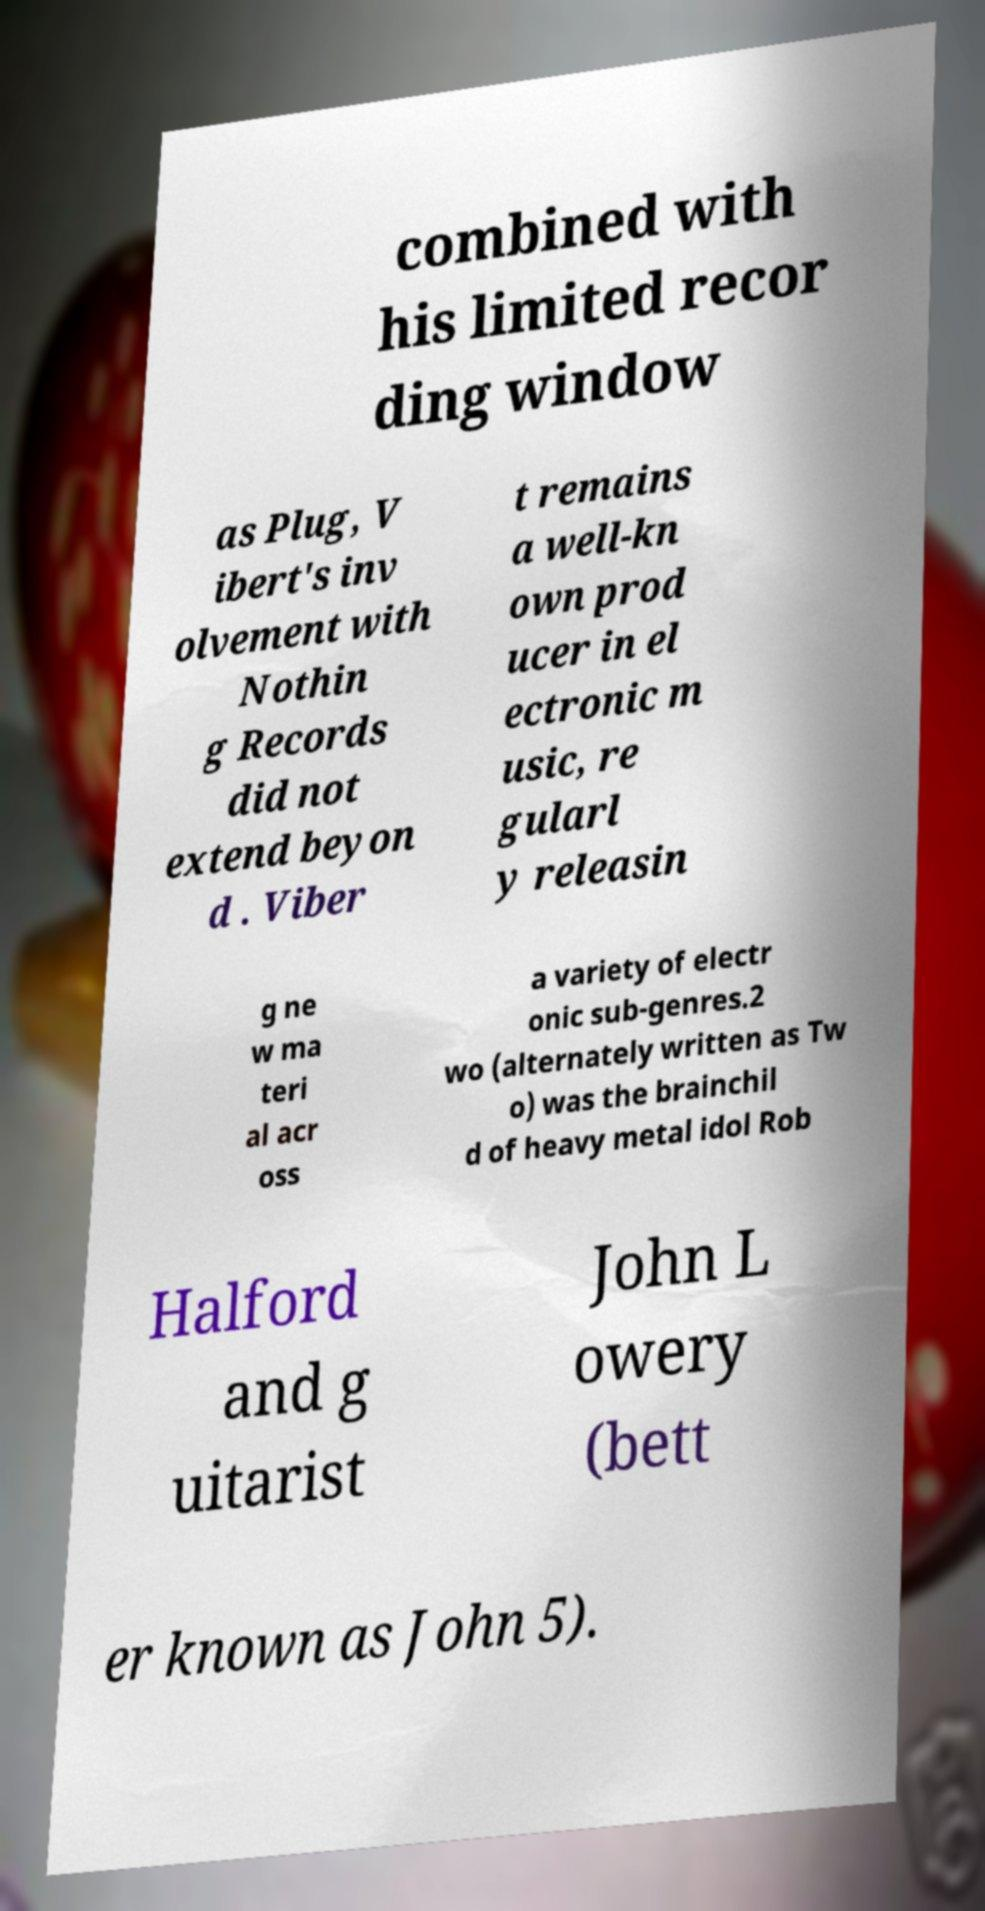Can you read and provide the text displayed in the image?This photo seems to have some interesting text. Can you extract and type it out for me? combined with his limited recor ding window as Plug, V ibert's inv olvement with Nothin g Records did not extend beyon d . Viber t remains a well-kn own prod ucer in el ectronic m usic, re gularl y releasin g ne w ma teri al acr oss a variety of electr onic sub-genres.2 wo (alternately written as Tw o) was the brainchil d of heavy metal idol Rob Halford and g uitarist John L owery (bett er known as John 5). 